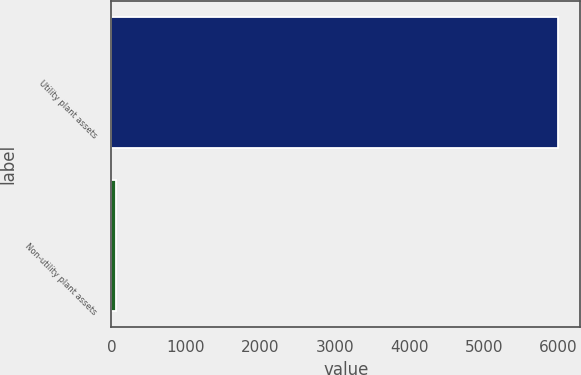<chart> <loc_0><loc_0><loc_500><loc_500><bar_chart><fcel>Utility plant assets<fcel>Non-utility plant assets<nl><fcel>5993<fcel>63<nl></chart> 